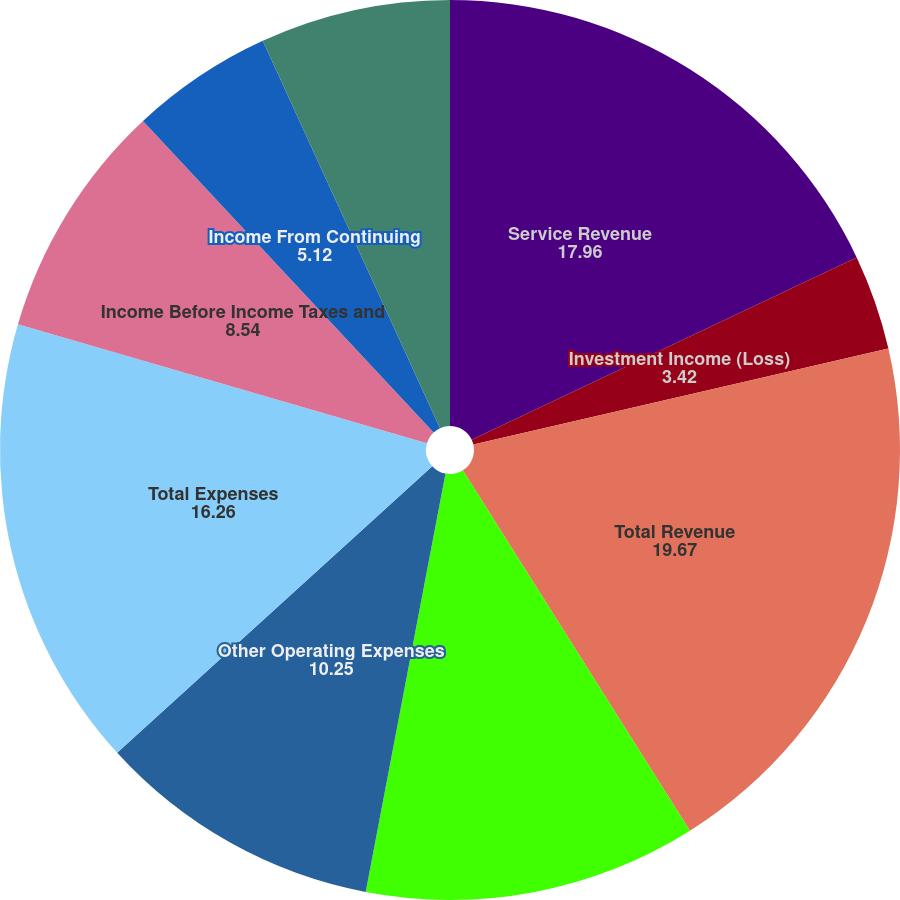Convert chart to OTSL. <chart><loc_0><loc_0><loc_500><loc_500><pie_chart><fcel>Service Revenue<fcel>Investment Income (Loss)<fcel>Total Revenue<fcel>Compensation and Benefits<fcel>Other Operating Expenses<fcel>Total Expenses<fcel>Income Before Income Taxes and<fcel>Income From Continuing<fcel>Discontinued Operations Net of<fcel>Net Income<nl><fcel>17.96%<fcel>3.42%<fcel>19.67%<fcel>11.95%<fcel>10.25%<fcel>16.26%<fcel>8.54%<fcel>5.12%<fcel>0.0%<fcel>6.83%<nl></chart> 